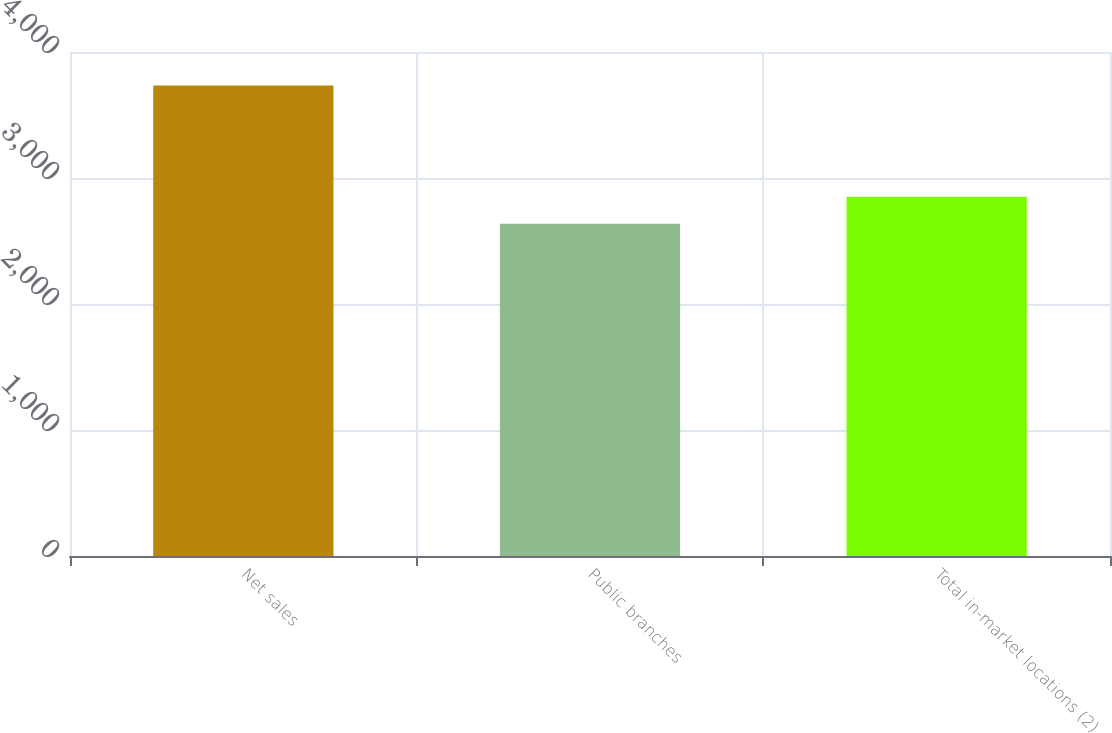Convert chart to OTSL. <chart><loc_0><loc_0><loc_500><loc_500><bar_chart><fcel>Net sales<fcel>Public branches<fcel>Total in-market locations (2)<nl><fcel>3733.5<fcel>2637<fcel>2851<nl></chart> 